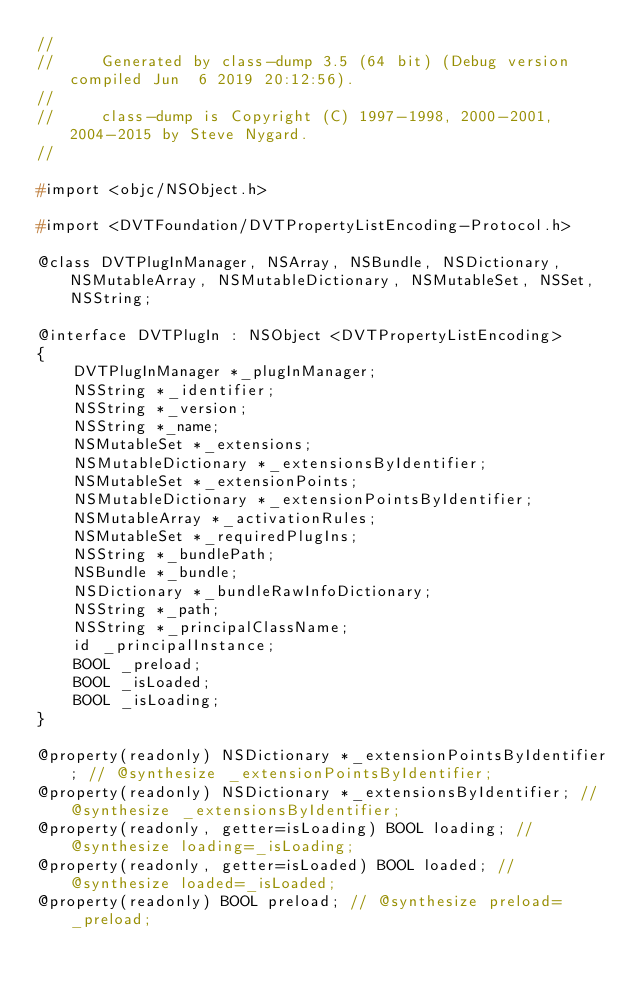Convert code to text. <code><loc_0><loc_0><loc_500><loc_500><_C_>//
//     Generated by class-dump 3.5 (64 bit) (Debug version compiled Jun  6 2019 20:12:56).
//
//     class-dump is Copyright (C) 1997-1998, 2000-2001, 2004-2015 by Steve Nygard.
//

#import <objc/NSObject.h>

#import <DVTFoundation/DVTPropertyListEncoding-Protocol.h>

@class DVTPlugInManager, NSArray, NSBundle, NSDictionary, NSMutableArray, NSMutableDictionary, NSMutableSet, NSSet, NSString;

@interface DVTPlugIn : NSObject <DVTPropertyListEncoding>
{
    DVTPlugInManager *_plugInManager;
    NSString *_identifier;
    NSString *_version;
    NSString *_name;
    NSMutableSet *_extensions;
    NSMutableDictionary *_extensionsByIdentifier;
    NSMutableSet *_extensionPoints;
    NSMutableDictionary *_extensionPointsByIdentifier;
    NSMutableArray *_activationRules;
    NSMutableSet *_requiredPlugIns;
    NSString *_bundlePath;
    NSBundle *_bundle;
    NSDictionary *_bundleRawInfoDictionary;
    NSString *_path;
    NSString *_principalClassName;
    id _principalInstance;
    BOOL _preload;
    BOOL _isLoaded;
    BOOL _isLoading;
}

@property(readonly) NSDictionary *_extensionPointsByIdentifier; // @synthesize _extensionPointsByIdentifier;
@property(readonly) NSDictionary *_extensionsByIdentifier; // @synthesize _extensionsByIdentifier;
@property(readonly, getter=isLoading) BOOL loading; // @synthesize loading=_isLoading;
@property(readonly, getter=isLoaded) BOOL loaded; // @synthesize loaded=_isLoaded;
@property(readonly) BOOL preload; // @synthesize preload=_preload;</code> 